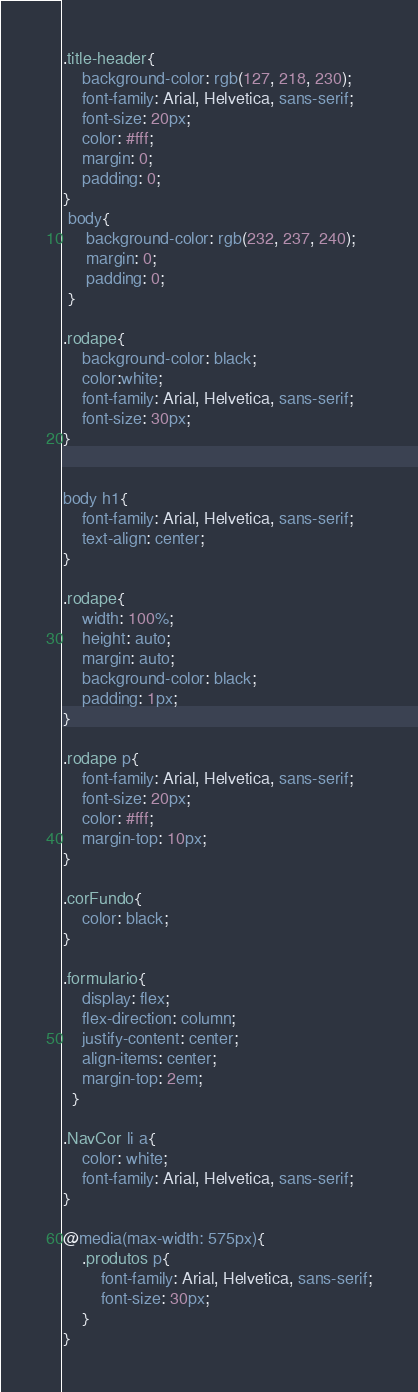Convert code to text. <code><loc_0><loc_0><loc_500><loc_500><_CSS_>.title-header{
	background-color: rgb(127, 218, 230);
	font-family: Arial, Helvetica, sans-serif;
	font-size: 20px;
	color: #fff;
	margin: 0;
	padding: 0;
}
 body{
	 background-color: rgb(232, 237, 240);
	 margin: 0;
	 padding: 0;
 }

.rodape{
	background-color: black;
	color:white;
	font-family: Arial, Helvetica, sans-serif;
	font-size: 30px;
}


body h1{
	font-family: Arial, Helvetica, sans-serif;
	text-align: center;
}

.rodape{
    width: 100%;
    height: auto;
    margin: auto;
    background-color: black;
    padding: 1px;
}

.rodape p{
	font-family: Arial, Helvetica, sans-serif;
	font-size: 20px;
	color: #fff;
	margin-top: 10px;
}

.corFundo{
	color: black;
}

.formulario{
	display: flex;
	flex-direction: column;
	justify-content: center;
	align-items: center;
	margin-top: 2em;
  }

.NavCor li a{
	color: white;
	font-family: Arial, Helvetica, sans-serif;
}

@media(max-width: 575px){
	.produtos p{
		font-family: Arial, Helvetica, sans-serif;
		font-size: 30px;
	}
}

</code> 